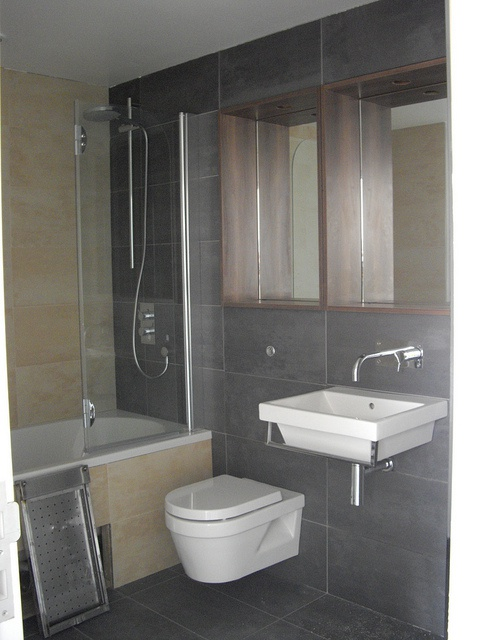Describe the objects in this image and their specific colors. I can see toilet in gray, darkgray, and lightgray tones and sink in gray, lightgray, and darkgray tones in this image. 